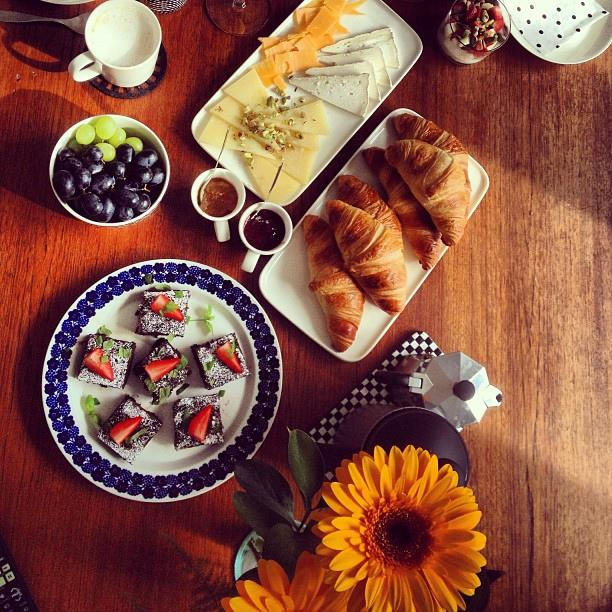Which people group invented the bread seen here? Please explain your reasoning. austrian. The bread on the plate is called a croissant and is famous in france. 